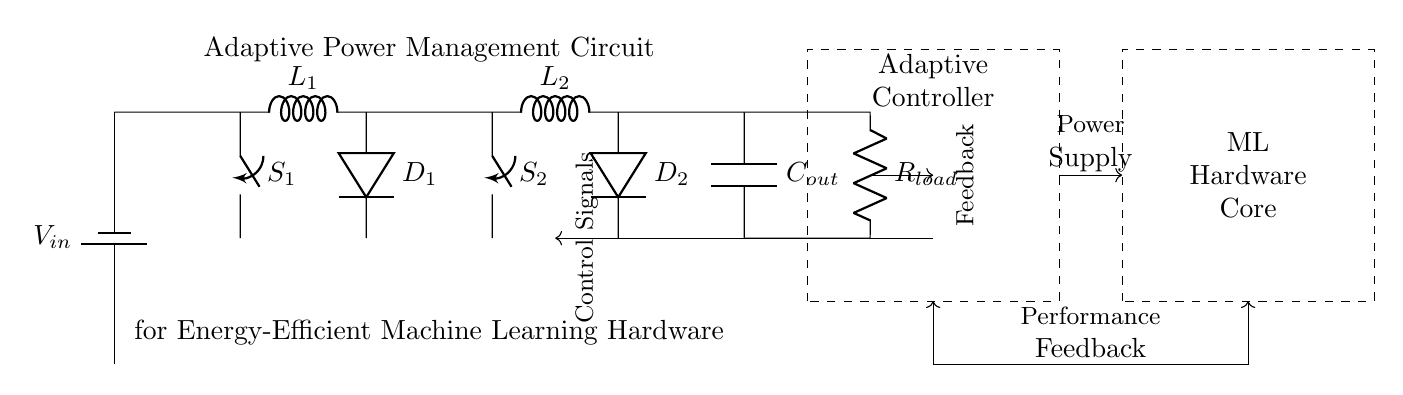What types of components are used in this circuit? The circuit contains batteries, inductors, switches, diodes, capacitors, resistors, and a controller block for power management.
Answer: batteries, inductors, switches, diodes, capacitors, resistors, controller What is the role of the adaptive controller? The adaptive controller receives feedback from the load and the machine learning core to adjust the power supplied to optimize energy efficiency.
Answer: optimize energy efficiency How many switches are present in the circuit? There are two switches indicated (S1 and S2) that control the flow of current through the buck converter stages.
Answer: two What do the inductors L1 and L2 do in the circuit? Inductors L1 and L2 are used in the buck converter section to store energy and regulate the output voltage.
Answer: store energy and regulate voltage Which two components are responsible for preventing current from flowing back into the buck converter? D1 and D2 are diodes that allow current to flow in one direction only, thus preventing reverse current from flowing back into the inductors.
Answer: D1 and D2 What type of feedback does the adaptive controller receive? The adaptive controller receives performance feedback from the machine learning hardware core to adjust the power management based on current consumption.
Answer: performance feedback How does the feedback from the load affect the control signals? The feedback from the load informs the controller about power requirements, leading to adjustments in control signals that regulate power delivery through the switches.
Answer: adjusts control signals 